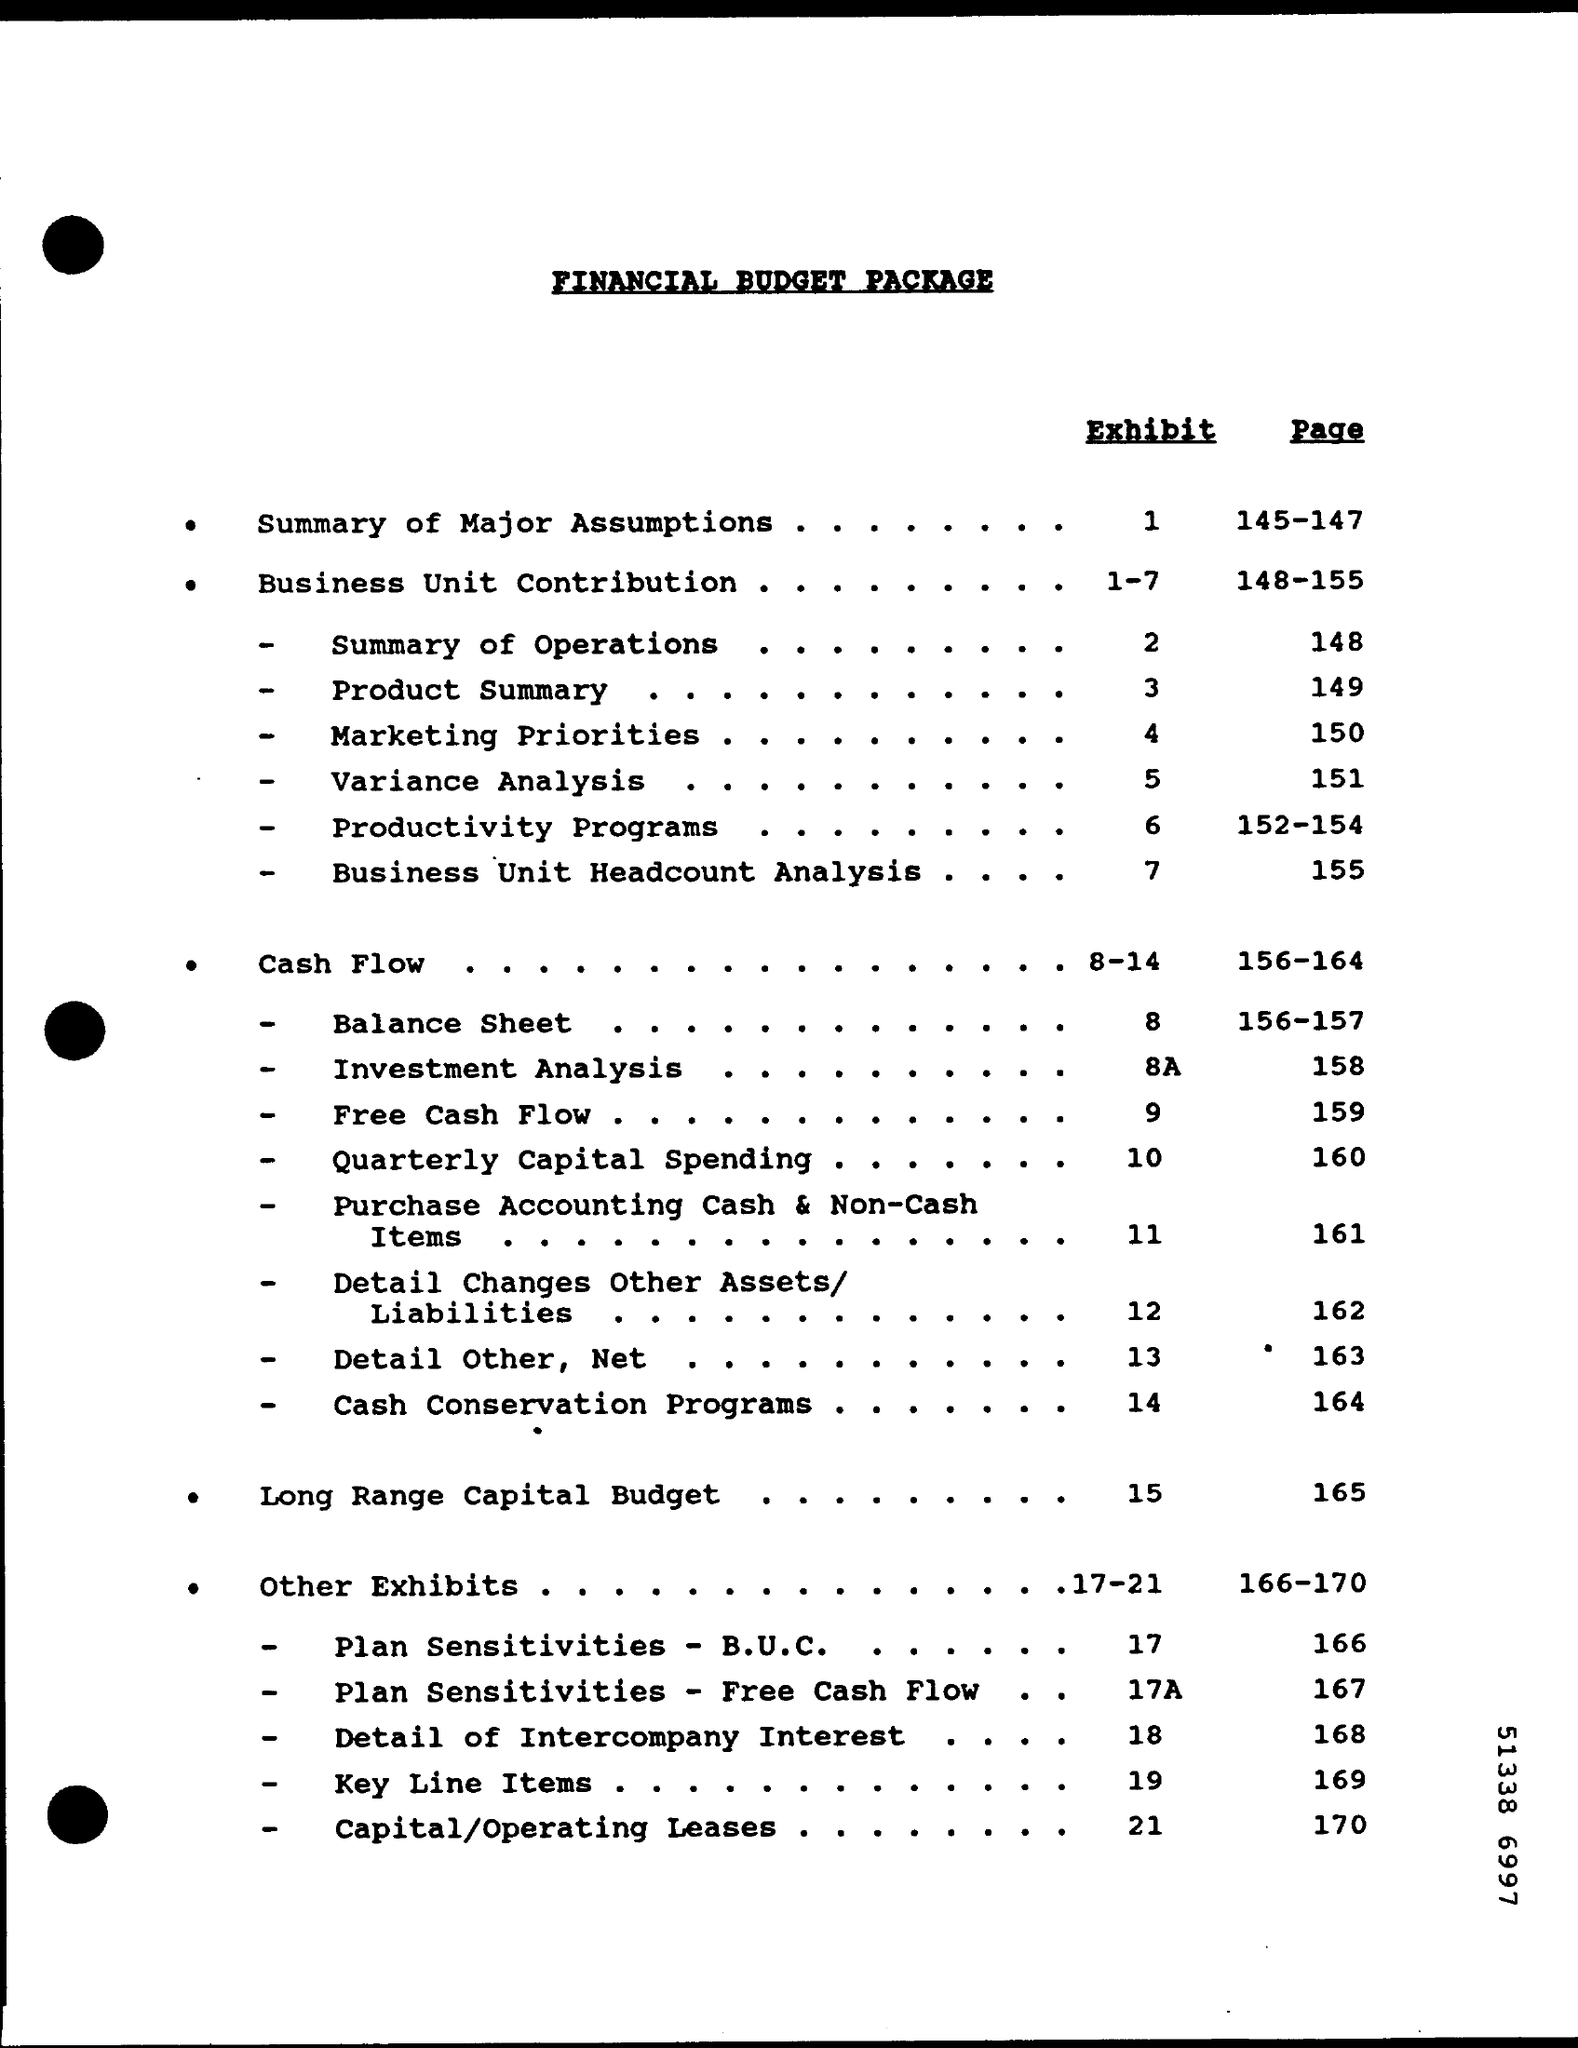Point out several critical features in this image. The exhibit displays the business unit contributions for each quarter from 1 to 7. The exhibits mentioned on pages 166 to 170 are located in which section? The exhibit number for the summary of major assumptions is 1. The balance sheet is provided in pages 156-157. The summary of the major assumptions can be found on pages 145 to 147. 